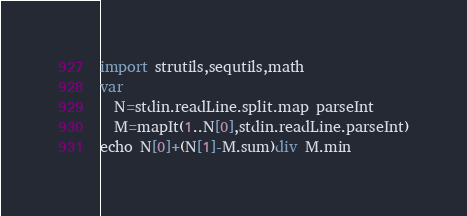<code> <loc_0><loc_0><loc_500><loc_500><_Nim_>import strutils,sequtils,math
var
  N=stdin.readLine.split.map parseInt
  M=mapIt(1..N[0],stdin.readLine.parseInt)
echo N[0]+(N[1]-M.sum)div M.min</code> 